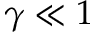Convert formula to latex. <formula><loc_0><loc_0><loc_500><loc_500>\gamma \ll 1</formula> 